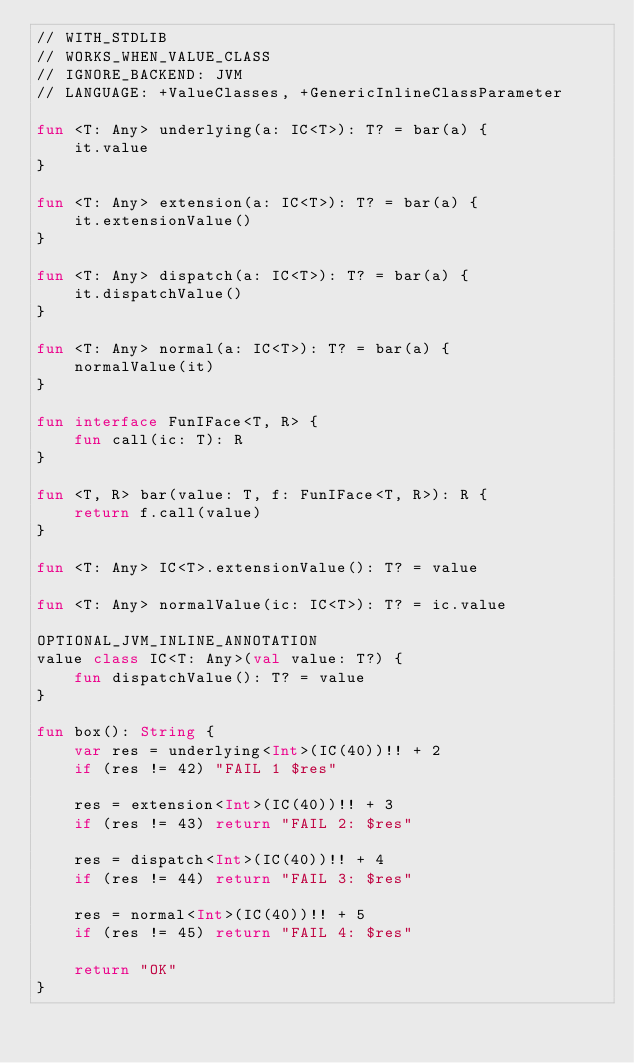Convert code to text. <code><loc_0><loc_0><loc_500><loc_500><_Kotlin_>// WITH_STDLIB
// WORKS_WHEN_VALUE_CLASS
// IGNORE_BACKEND: JVM
// LANGUAGE: +ValueClasses, +GenericInlineClassParameter

fun <T: Any> underlying(a: IC<T>): T? = bar(a) {
    it.value
}

fun <T: Any> extension(a: IC<T>): T? = bar(a) {
    it.extensionValue()
}

fun <T: Any> dispatch(a: IC<T>): T? = bar(a) {
    it.dispatchValue()
}

fun <T: Any> normal(a: IC<T>): T? = bar(a) {
    normalValue(it)
}

fun interface FunIFace<T, R> {
    fun call(ic: T): R
}

fun <T, R> bar(value: T, f: FunIFace<T, R>): R {
    return f.call(value)
}

fun <T: Any> IC<T>.extensionValue(): T? = value

fun <T: Any> normalValue(ic: IC<T>): T? = ic.value

OPTIONAL_JVM_INLINE_ANNOTATION
value class IC<T: Any>(val value: T?) {
    fun dispatchValue(): T? = value
}

fun box(): String {
    var res = underlying<Int>(IC(40))!! + 2
    if (res != 42) "FAIL 1 $res"

    res = extension<Int>(IC(40))!! + 3
    if (res != 43) return "FAIL 2: $res"

    res = dispatch<Int>(IC(40))!! + 4
    if (res != 44) return "FAIL 3: $res"

    res = normal<Int>(IC(40))!! + 5
    if (res != 45) return "FAIL 4: $res"

    return "OK"
}</code> 